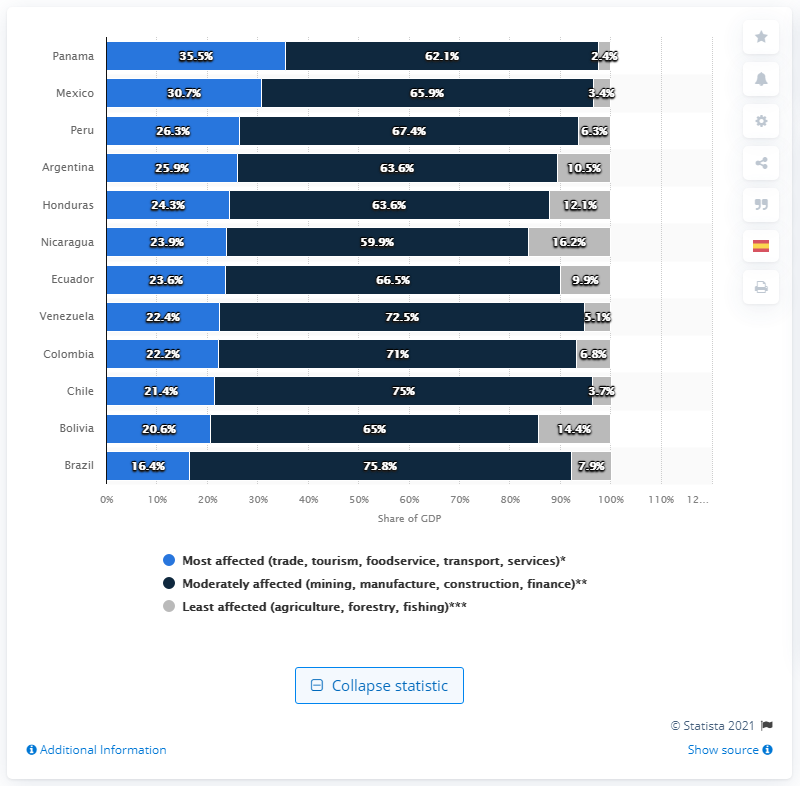Identify some key points in this picture. The COVID-19 pandemic has had a moderate impact on approximately 75.8% of Brazil's GDP. 